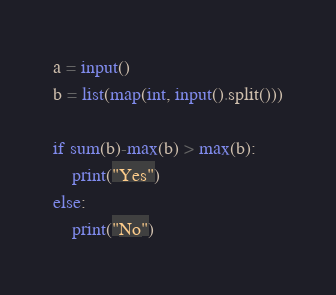<code> <loc_0><loc_0><loc_500><loc_500><_Python_>a = input()
b = list(map(int, input().split()))

if sum(b)-max(b) > max(b):
    print("Yes")
else:
    print("No")</code> 